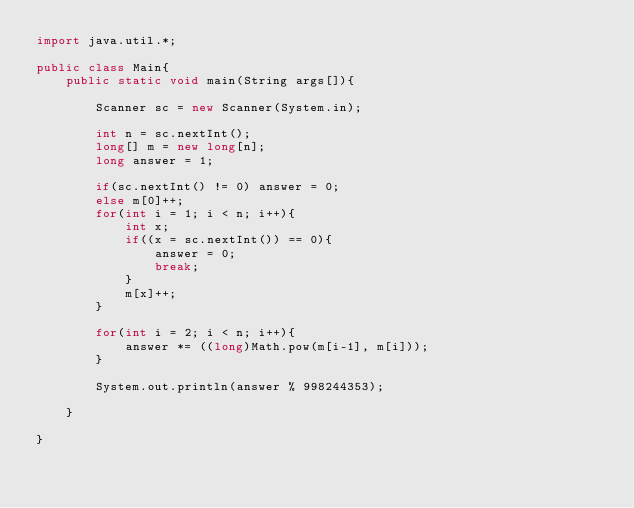Convert code to text. <code><loc_0><loc_0><loc_500><loc_500><_Java_>import java.util.*;

public class Main{
    public static void main(String args[]){

        Scanner sc = new Scanner(System.in);

        int n = sc.nextInt();
        long[] m = new long[n];
        long answer = 1;

        if(sc.nextInt() != 0) answer = 0;
        else m[0]++;
        for(int i = 1; i < n; i++){
            int x;
            if((x = sc.nextInt()) == 0){
                answer = 0;
                break;
            }
            m[x]++;
        }

        for(int i = 2; i < n; i++){
            answer *= ((long)Math.pow(m[i-1], m[i]));
        }

        System.out.println(answer % 998244353);

    }

}
</code> 